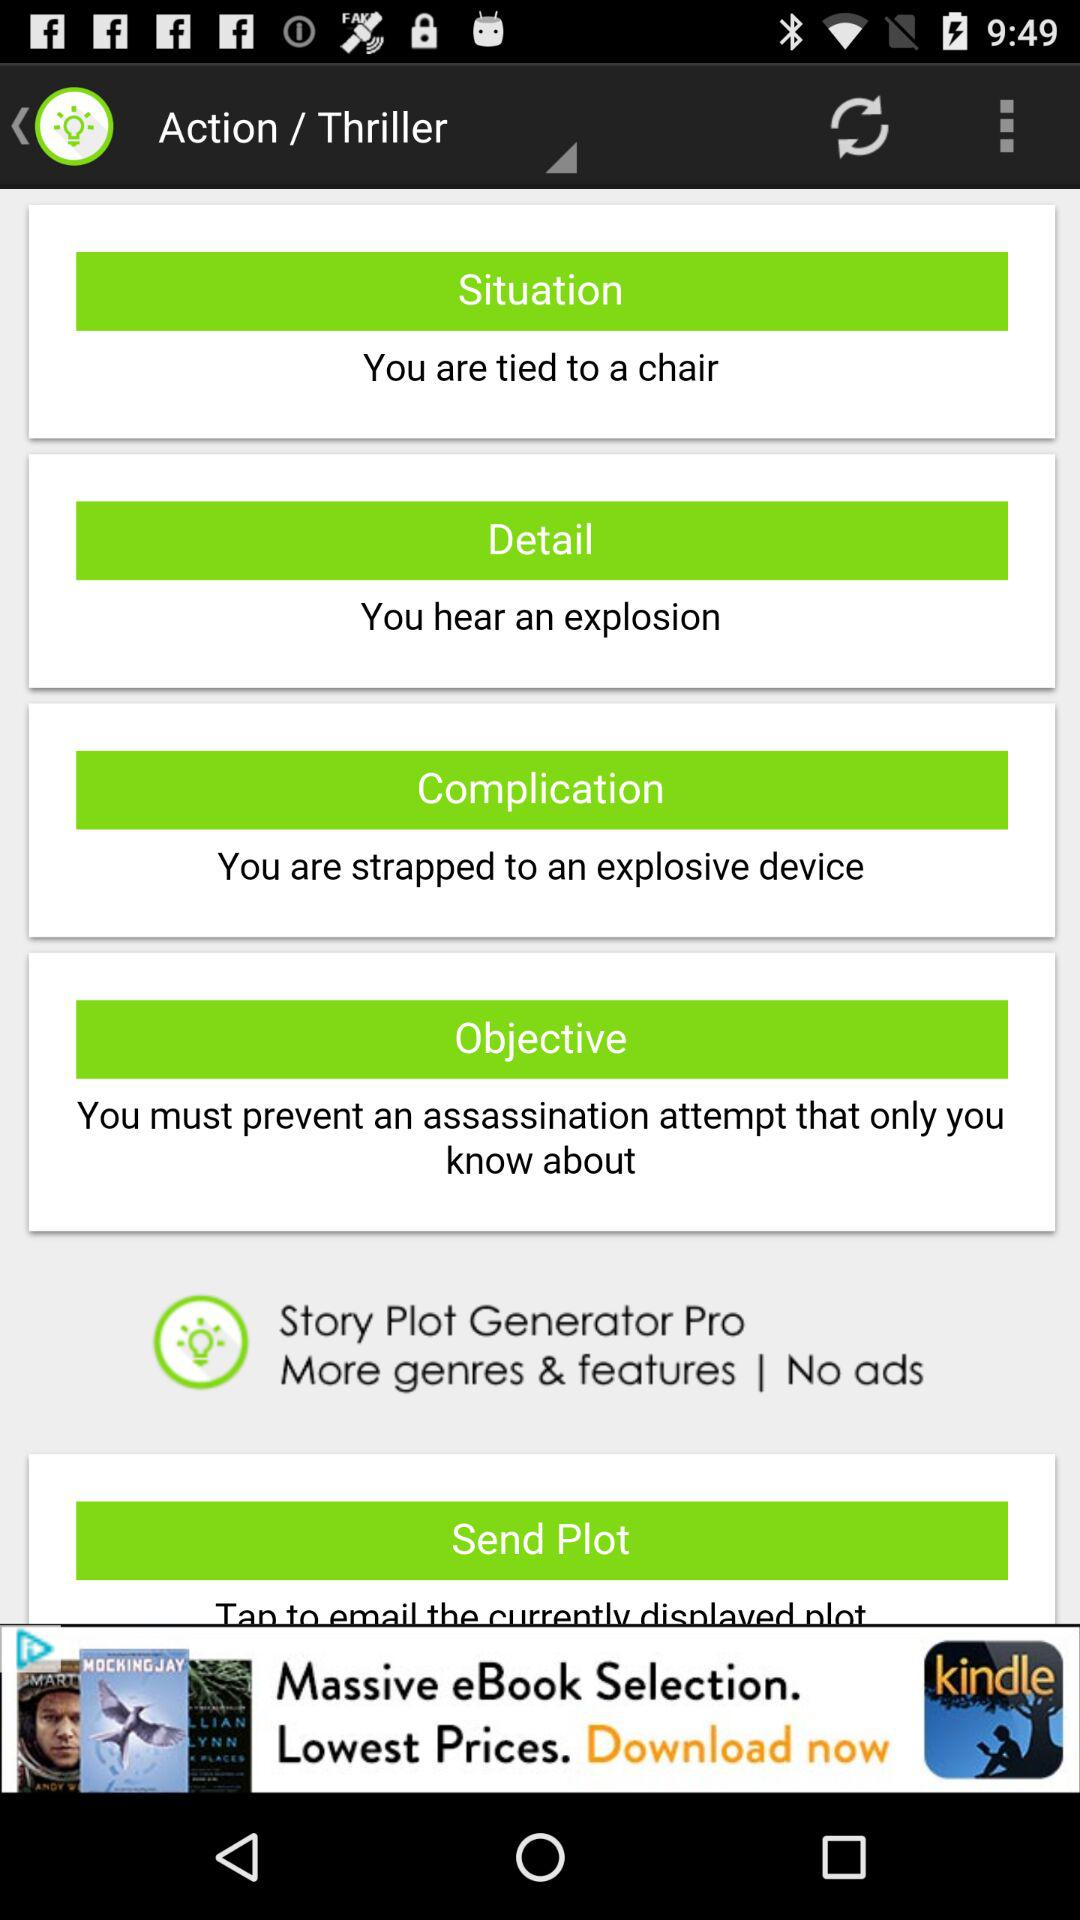What is the name of the application? The name of the application is "Story Plot Generator Pro". 